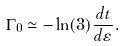Convert formula to latex. <formula><loc_0><loc_0><loc_500><loc_500>\Gamma _ { 0 } \simeq - \ln ( 3 ) \frac { d t } { d \varepsilon } .</formula> 